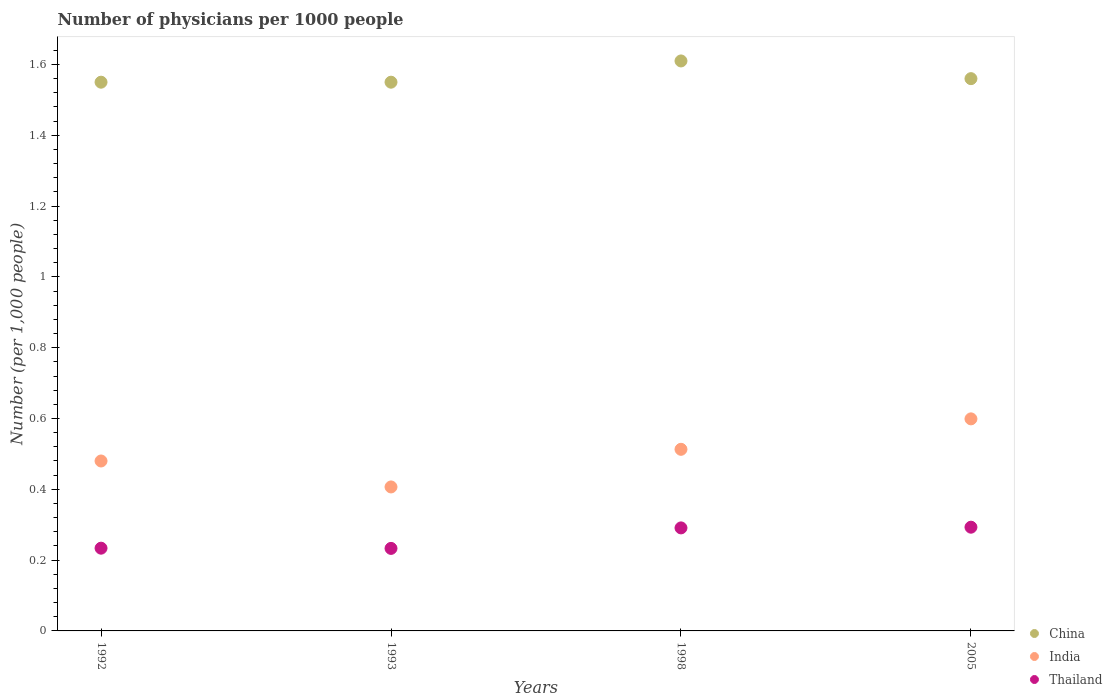Is the number of dotlines equal to the number of legend labels?
Your answer should be compact. Yes. What is the number of physicians in China in 1992?
Ensure brevity in your answer.  1.55. Across all years, what is the maximum number of physicians in India?
Ensure brevity in your answer.  0.6. Across all years, what is the minimum number of physicians in Thailand?
Your answer should be compact. 0.23. What is the total number of physicians in India in the graph?
Keep it short and to the point. 2. What is the difference between the number of physicians in China in 1992 and that in 2005?
Provide a succinct answer. -0.01. What is the difference between the number of physicians in India in 1993 and the number of physicians in Thailand in 2005?
Your answer should be compact. 0.11. What is the average number of physicians in India per year?
Offer a very short reply. 0.5. In the year 1992, what is the difference between the number of physicians in China and number of physicians in India?
Provide a succinct answer. 1.07. What is the ratio of the number of physicians in Thailand in 1993 to that in 2005?
Give a very brief answer. 0.8. What is the difference between the highest and the second highest number of physicians in India?
Provide a succinct answer. 0.09. What is the difference between the highest and the lowest number of physicians in China?
Ensure brevity in your answer.  0.06. In how many years, is the number of physicians in Thailand greater than the average number of physicians in Thailand taken over all years?
Offer a very short reply. 2. Is the sum of the number of physicians in Thailand in 1992 and 1993 greater than the maximum number of physicians in China across all years?
Keep it short and to the point. No. Is it the case that in every year, the sum of the number of physicians in Thailand and number of physicians in India  is greater than the number of physicians in China?
Provide a succinct answer. No. Is the number of physicians in Thailand strictly less than the number of physicians in India over the years?
Give a very brief answer. Yes. How many dotlines are there?
Give a very brief answer. 3. How many years are there in the graph?
Keep it short and to the point. 4. Are the values on the major ticks of Y-axis written in scientific E-notation?
Provide a succinct answer. No. Does the graph contain grids?
Provide a succinct answer. No. How are the legend labels stacked?
Your answer should be compact. Vertical. What is the title of the graph?
Your answer should be compact. Number of physicians per 1000 people. Does "Macao" appear as one of the legend labels in the graph?
Provide a succinct answer. No. What is the label or title of the X-axis?
Make the answer very short. Years. What is the label or title of the Y-axis?
Your answer should be very brief. Number (per 1,0 people). What is the Number (per 1,000 people) of China in 1992?
Your answer should be compact. 1.55. What is the Number (per 1,000 people) in India in 1992?
Make the answer very short. 0.48. What is the Number (per 1,000 people) of Thailand in 1992?
Ensure brevity in your answer.  0.23. What is the Number (per 1,000 people) in China in 1993?
Your answer should be very brief. 1.55. What is the Number (per 1,000 people) in India in 1993?
Provide a short and direct response. 0.41. What is the Number (per 1,000 people) of Thailand in 1993?
Provide a short and direct response. 0.23. What is the Number (per 1,000 people) in China in 1998?
Provide a succinct answer. 1.61. What is the Number (per 1,000 people) of India in 1998?
Your answer should be very brief. 0.51. What is the Number (per 1,000 people) in Thailand in 1998?
Offer a very short reply. 0.29. What is the Number (per 1,000 people) of China in 2005?
Give a very brief answer. 1.56. What is the Number (per 1,000 people) of India in 2005?
Your response must be concise. 0.6. What is the Number (per 1,000 people) of Thailand in 2005?
Offer a very short reply. 0.29. Across all years, what is the maximum Number (per 1,000 people) of China?
Your answer should be very brief. 1.61. Across all years, what is the maximum Number (per 1,000 people) in India?
Provide a short and direct response. 0.6. Across all years, what is the maximum Number (per 1,000 people) in Thailand?
Ensure brevity in your answer.  0.29. Across all years, what is the minimum Number (per 1,000 people) of China?
Make the answer very short. 1.55. Across all years, what is the minimum Number (per 1,000 people) of India?
Provide a succinct answer. 0.41. Across all years, what is the minimum Number (per 1,000 people) in Thailand?
Keep it short and to the point. 0.23. What is the total Number (per 1,000 people) of China in the graph?
Offer a very short reply. 6.27. What is the total Number (per 1,000 people) of India in the graph?
Your answer should be very brief. 2. What is the total Number (per 1,000 people) in Thailand in the graph?
Your response must be concise. 1.05. What is the difference between the Number (per 1,000 people) in India in 1992 and that in 1993?
Keep it short and to the point. 0.07. What is the difference between the Number (per 1,000 people) in Thailand in 1992 and that in 1993?
Keep it short and to the point. 0. What is the difference between the Number (per 1,000 people) of China in 1992 and that in 1998?
Keep it short and to the point. -0.06. What is the difference between the Number (per 1,000 people) of India in 1992 and that in 1998?
Offer a terse response. -0.03. What is the difference between the Number (per 1,000 people) in Thailand in 1992 and that in 1998?
Ensure brevity in your answer.  -0.06. What is the difference between the Number (per 1,000 people) in China in 1992 and that in 2005?
Provide a short and direct response. -0.01. What is the difference between the Number (per 1,000 people) in India in 1992 and that in 2005?
Your answer should be very brief. -0.12. What is the difference between the Number (per 1,000 people) in Thailand in 1992 and that in 2005?
Your answer should be compact. -0.06. What is the difference between the Number (per 1,000 people) in China in 1993 and that in 1998?
Your answer should be very brief. -0.06. What is the difference between the Number (per 1,000 people) of India in 1993 and that in 1998?
Provide a succinct answer. -0.11. What is the difference between the Number (per 1,000 people) in Thailand in 1993 and that in 1998?
Make the answer very short. -0.06. What is the difference between the Number (per 1,000 people) in China in 1993 and that in 2005?
Make the answer very short. -0.01. What is the difference between the Number (per 1,000 people) of India in 1993 and that in 2005?
Ensure brevity in your answer.  -0.19. What is the difference between the Number (per 1,000 people) in Thailand in 1993 and that in 2005?
Provide a short and direct response. -0.06. What is the difference between the Number (per 1,000 people) of India in 1998 and that in 2005?
Your response must be concise. -0.09. What is the difference between the Number (per 1,000 people) of Thailand in 1998 and that in 2005?
Offer a terse response. -0. What is the difference between the Number (per 1,000 people) of China in 1992 and the Number (per 1,000 people) of India in 1993?
Provide a short and direct response. 1.14. What is the difference between the Number (per 1,000 people) in China in 1992 and the Number (per 1,000 people) in Thailand in 1993?
Offer a very short reply. 1.32. What is the difference between the Number (per 1,000 people) of India in 1992 and the Number (per 1,000 people) of Thailand in 1993?
Provide a succinct answer. 0.25. What is the difference between the Number (per 1,000 people) in China in 1992 and the Number (per 1,000 people) in India in 1998?
Your answer should be very brief. 1.04. What is the difference between the Number (per 1,000 people) in China in 1992 and the Number (per 1,000 people) in Thailand in 1998?
Provide a short and direct response. 1.26. What is the difference between the Number (per 1,000 people) in India in 1992 and the Number (per 1,000 people) in Thailand in 1998?
Make the answer very short. 0.19. What is the difference between the Number (per 1,000 people) in China in 1992 and the Number (per 1,000 people) in India in 2005?
Your answer should be very brief. 0.95. What is the difference between the Number (per 1,000 people) in China in 1992 and the Number (per 1,000 people) in Thailand in 2005?
Keep it short and to the point. 1.26. What is the difference between the Number (per 1,000 people) of India in 1992 and the Number (per 1,000 people) of Thailand in 2005?
Your answer should be very brief. 0.19. What is the difference between the Number (per 1,000 people) of China in 1993 and the Number (per 1,000 people) of India in 1998?
Keep it short and to the point. 1.04. What is the difference between the Number (per 1,000 people) of China in 1993 and the Number (per 1,000 people) of Thailand in 1998?
Ensure brevity in your answer.  1.26. What is the difference between the Number (per 1,000 people) of India in 1993 and the Number (per 1,000 people) of Thailand in 1998?
Keep it short and to the point. 0.12. What is the difference between the Number (per 1,000 people) of China in 1993 and the Number (per 1,000 people) of India in 2005?
Keep it short and to the point. 0.95. What is the difference between the Number (per 1,000 people) in China in 1993 and the Number (per 1,000 people) in Thailand in 2005?
Give a very brief answer. 1.26. What is the difference between the Number (per 1,000 people) in India in 1993 and the Number (per 1,000 people) in Thailand in 2005?
Provide a short and direct response. 0.11. What is the difference between the Number (per 1,000 people) of China in 1998 and the Number (per 1,000 people) of India in 2005?
Ensure brevity in your answer.  1.01. What is the difference between the Number (per 1,000 people) of China in 1998 and the Number (per 1,000 people) of Thailand in 2005?
Make the answer very short. 1.32. What is the difference between the Number (per 1,000 people) of India in 1998 and the Number (per 1,000 people) of Thailand in 2005?
Your answer should be compact. 0.22. What is the average Number (per 1,000 people) in China per year?
Offer a terse response. 1.57. What is the average Number (per 1,000 people) in India per year?
Give a very brief answer. 0.5. What is the average Number (per 1,000 people) of Thailand per year?
Provide a short and direct response. 0.26. In the year 1992, what is the difference between the Number (per 1,000 people) in China and Number (per 1,000 people) in India?
Offer a terse response. 1.07. In the year 1992, what is the difference between the Number (per 1,000 people) in China and Number (per 1,000 people) in Thailand?
Ensure brevity in your answer.  1.32. In the year 1992, what is the difference between the Number (per 1,000 people) in India and Number (per 1,000 people) in Thailand?
Your answer should be very brief. 0.25. In the year 1993, what is the difference between the Number (per 1,000 people) in China and Number (per 1,000 people) in India?
Provide a succinct answer. 1.14. In the year 1993, what is the difference between the Number (per 1,000 people) of China and Number (per 1,000 people) of Thailand?
Provide a succinct answer. 1.32. In the year 1993, what is the difference between the Number (per 1,000 people) in India and Number (per 1,000 people) in Thailand?
Ensure brevity in your answer.  0.17. In the year 1998, what is the difference between the Number (per 1,000 people) in China and Number (per 1,000 people) in India?
Your answer should be very brief. 1.1. In the year 1998, what is the difference between the Number (per 1,000 people) of China and Number (per 1,000 people) of Thailand?
Give a very brief answer. 1.32. In the year 1998, what is the difference between the Number (per 1,000 people) of India and Number (per 1,000 people) of Thailand?
Make the answer very short. 0.22. In the year 2005, what is the difference between the Number (per 1,000 people) in China and Number (per 1,000 people) in India?
Keep it short and to the point. 0.96. In the year 2005, what is the difference between the Number (per 1,000 people) of China and Number (per 1,000 people) of Thailand?
Provide a succinct answer. 1.27. In the year 2005, what is the difference between the Number (per 1,000 people) of India and Number (per 1,000 people) of Thailand?
Your response must be concise. 0.31. What is the ratio of the Number (per 1,000 people) of India in 1992 to that in 1993?
Your response must be concise. 1.18. What is the ratio of the Number (per 1,000 people) in China in 1992 to that in 1998?
Keep it short and to the point. 0.96. What is the ratio of the Number (per 1,000 people) in India in 1992 to that in 1998?
Offer a very short reply. 0.94. What is the ratio of the Number (per 1,000 people) of Thailand in 1992 to that in 1998?
Make the answer very short. 0.8. What is the ratio of the Number (per 1,000 people) of China in 1992 to that in 2005?
Make the answer very short. 0.99. What is the ratio of the Number (per 1,000 people) in India in 1992 to that in 2005?
Your answer should be compact. 0.8. What is the ratio of the Number (per 1,000 people) of Thailand in 1992 to that in 2005?
Ensure brevity in your answer.  0.8. What is the ratio of the Number (per 1,000 people) in China in 1993 to that in 1998?
Offer a terse response. 0.96. What is the ratio of the Number (per 1,000 people) in India in 1993 to that in 1998?
Your response must be concise. 0.79. What is the ratio of the Number (per 1,000 people) of Thailand in 1993 to that in 1998?
Your answer should be compact. 0.8. What is the ratio of the Number (per 1,000 people) of India in 1993 to that in 2005?
Ensure brevity in your answer.  0.68. What is the ratio of the Number (per 1,000 people) of Thailand in 1993 to that in 2005?
Make the answer very short. 0.8. What is the ratio of the Number (per 1,000 people) in China in 1998 to that in 2005?
Make the answer very short. 1.03. What is the ratio of the Number (per 1,000 people) in India in 1998 to that in 2005?
Offer a terse response. 0.86. What is the difference between the highest and the second highest Number (per 1,000 people) of China?
Your answer should be very brief. 0.05. What is the difference between the highest and the second highest Number (per 1,000 people) in India?
Your response must be concise. 0.09. What is the difference between the highest and the second highest Number (per 1,000 people) in Thailand?
Provide a succinct answer. 0. What is the difference between the highest and the lowest Number (per 1,000 people) of India?
Give a very brief answer. 0.19. What is the difference between the highest and the lowest Number (per 1,000 people) of Thailand?
Make the answer very short. 0.06. 